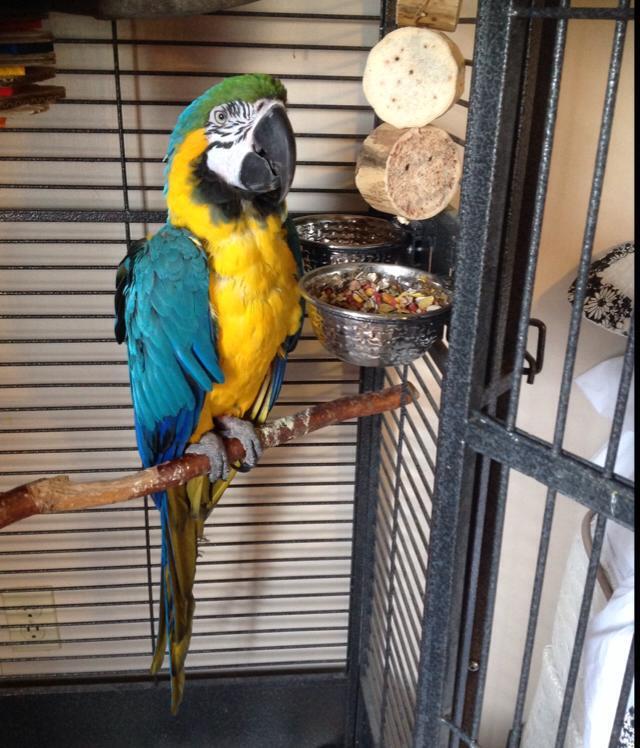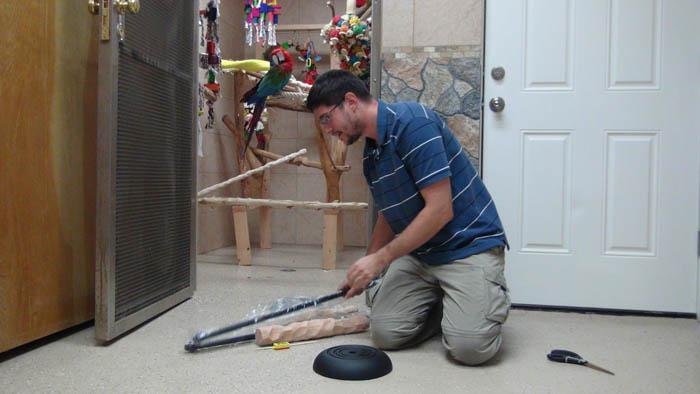The first image is the image on the left, the second image is the image on the right. For the images shown, is this caption "A person in long dark sleeves holds a hand near the beak of a perching blue-and-yellow parrot, in one image." true? Answer yes or no. No. The first image is the image on the left, the second image is the image on the right. Considering the images on both sides, is "One of the humans visible is wearing a long-sleeved shirt." valid? Answer yes or no. No. 